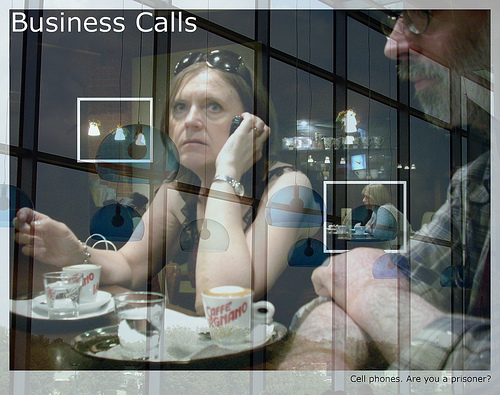Is the telephone in the top or in the bottom of the photo? The telephone is in the top part of the photo. 